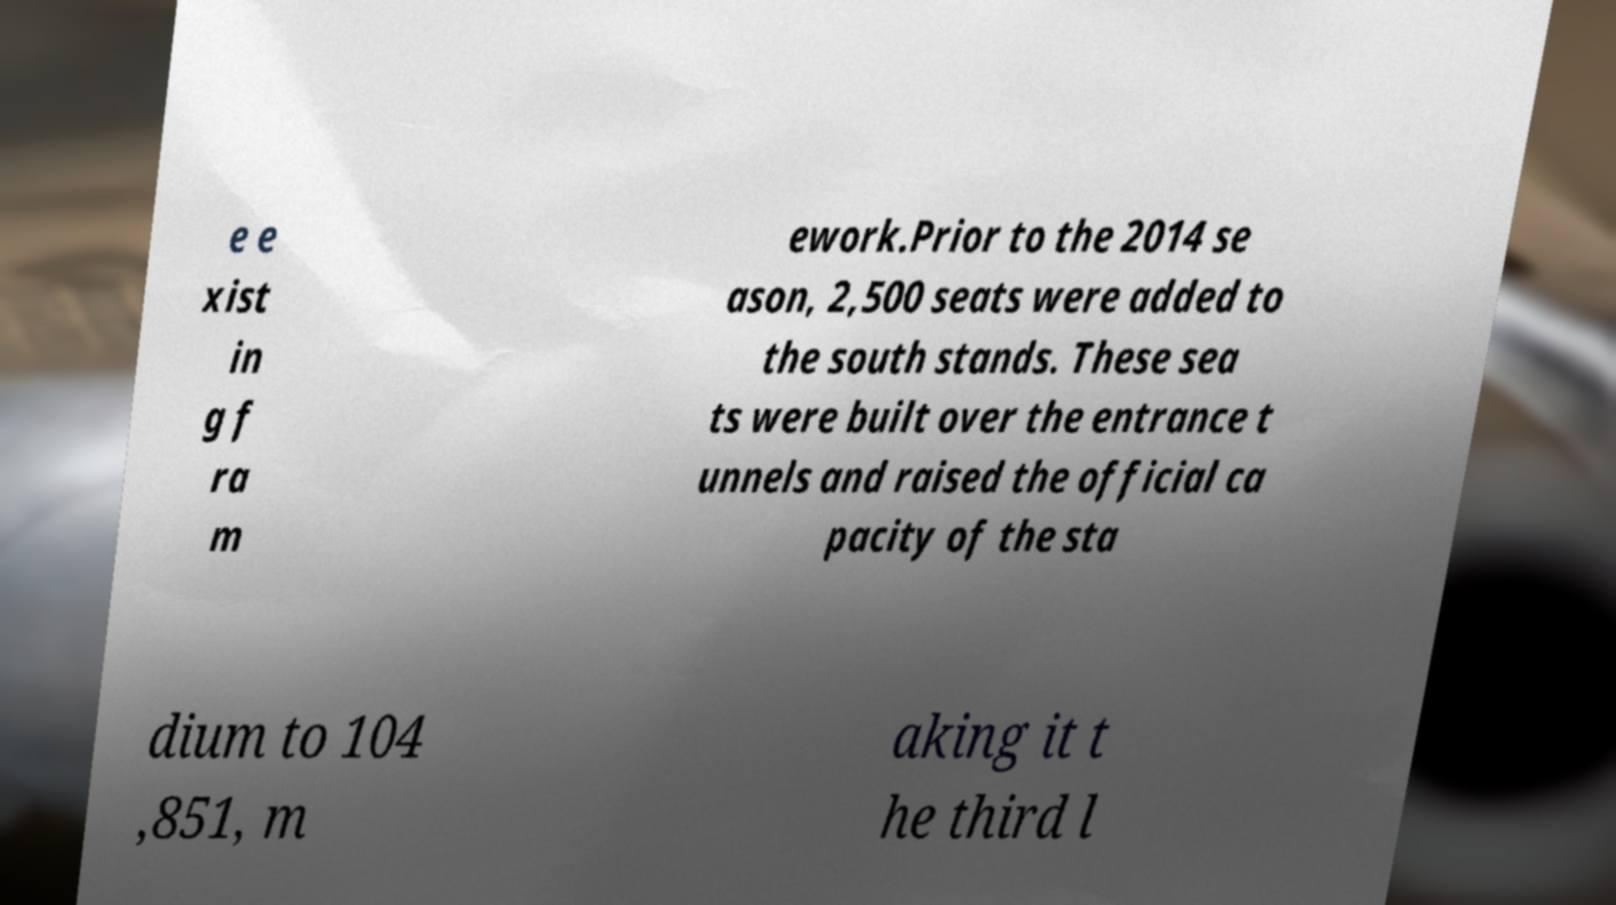Could you extract and type out the text from this image? e e xist in g f ra m ework.Prior to the 2014 se ason, 2,500 seats were added to the south stands. These sea ts were built over the entrance t unnels and raised the official ca pacity of the sta dium to 104 ,851, m aking it t he third l 